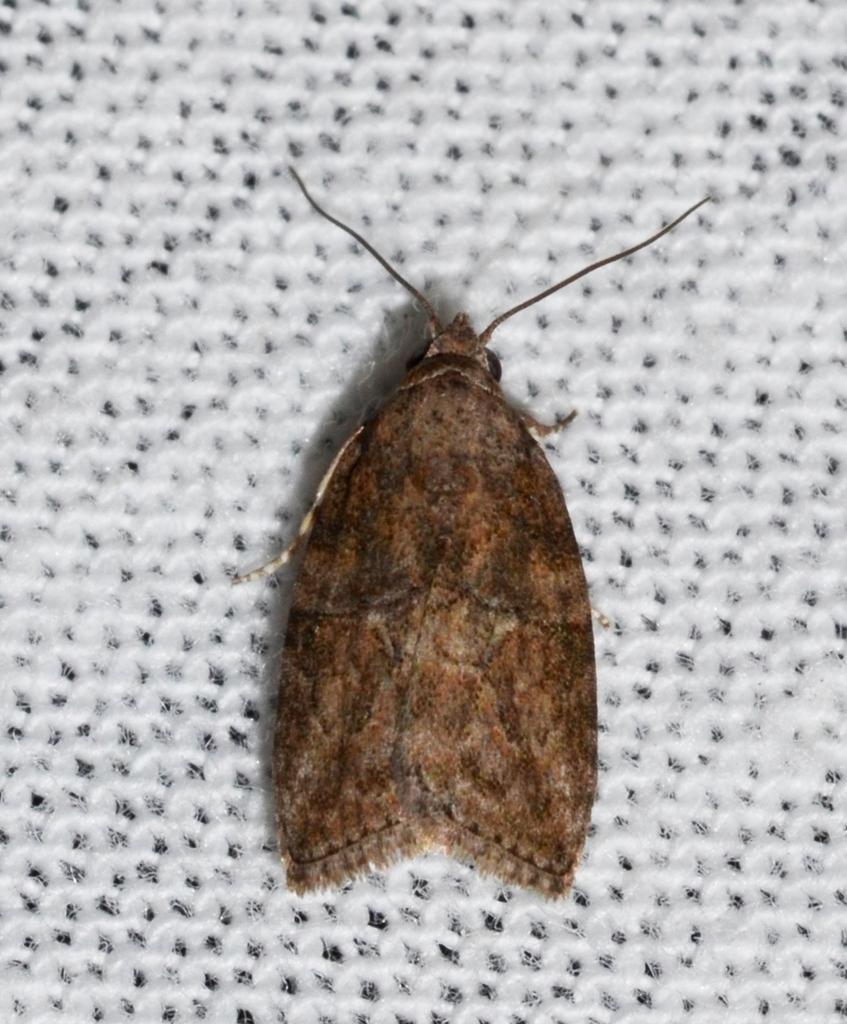Describe this image in one or two sentences. In this image there is an insect on the surface which is white in colour. 